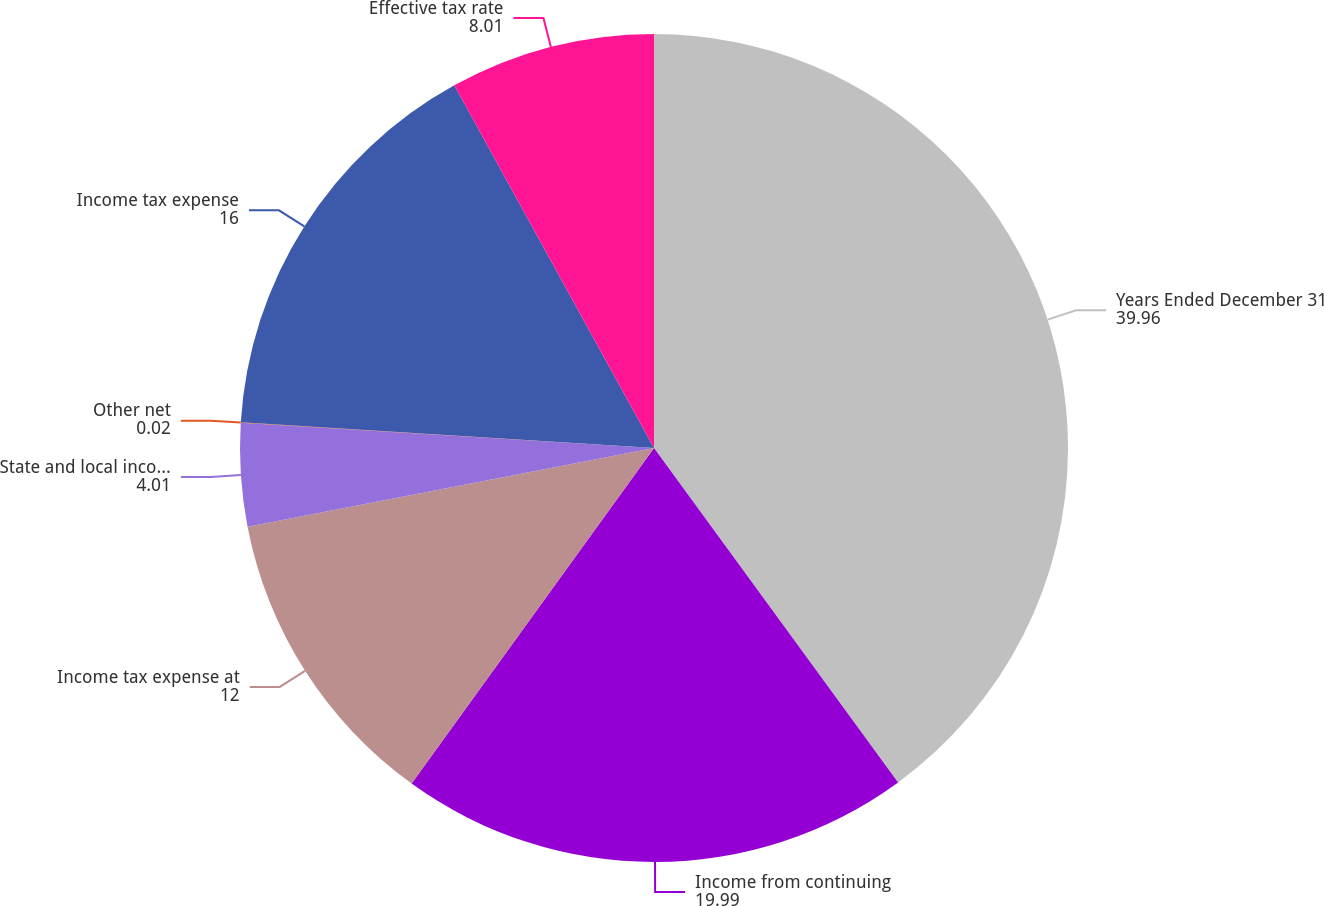<chart> <loc_0><loc_0><loc_500><loc_500><pie_chart><fcel>Years Ended December 31<fcel>Income from continuing<fcel>Income tax expense at<fcel>State and local income taxes<fcel>Other net<fcel>Income tax expense<fcel>Effective tax rate<nl><fcel>39.96%<fcel>19.99%<fcel>12.0%<fcel>4.01%<fcel>0.02%<fcel>16.0%<fcel>8.01%<nl></chart> 